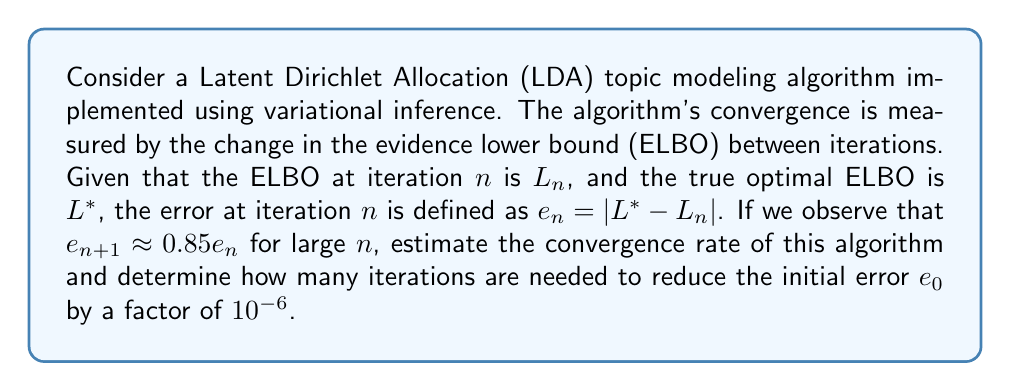What is the answer to this math problem? To solve this problem, we'll follow these steps:

1) First, let's identify the convergence rate. The given relation $e_{n+1} \approx 0.85e_n$ implies a linear convergence rate. The factor 0.85 is the convergence rate per iteration.

2) To determine the number of iterations needed, we can use the following relation:

   $$e_n = (0.85)^n e_0$$

3) We want to find $n$ such that:

   $$\frac{e_n}{e_0} = 10^{-6}$$

4) Substituting the expression for $e_n$:

   $$\frac{(0.85)^n e_0}{e_0} = 10^{-6}$$

5) The $e_0$ terms cancel out:

   $$(0.85)^n = 10^{-6}$$

6) Taking the logarithm of both sides:

   $$n \log(0.85) = \log(10^{-6}) = -6 \log(10)$$

7) Solving for $n$:

   $$n = \frac{-6 \log(10)}{\log(0.85)} \approx 87.68$$

8) Since we need a whole number of iterations, we round up to 88.

Therefore, the convergence rate is 0.85 per iteration, and it will take 88 iterations to reduce the initial error by a factor of $10^{-6}$.
Answer: Convergence rate: 0.85 per iteration
Number of iterations: 88 